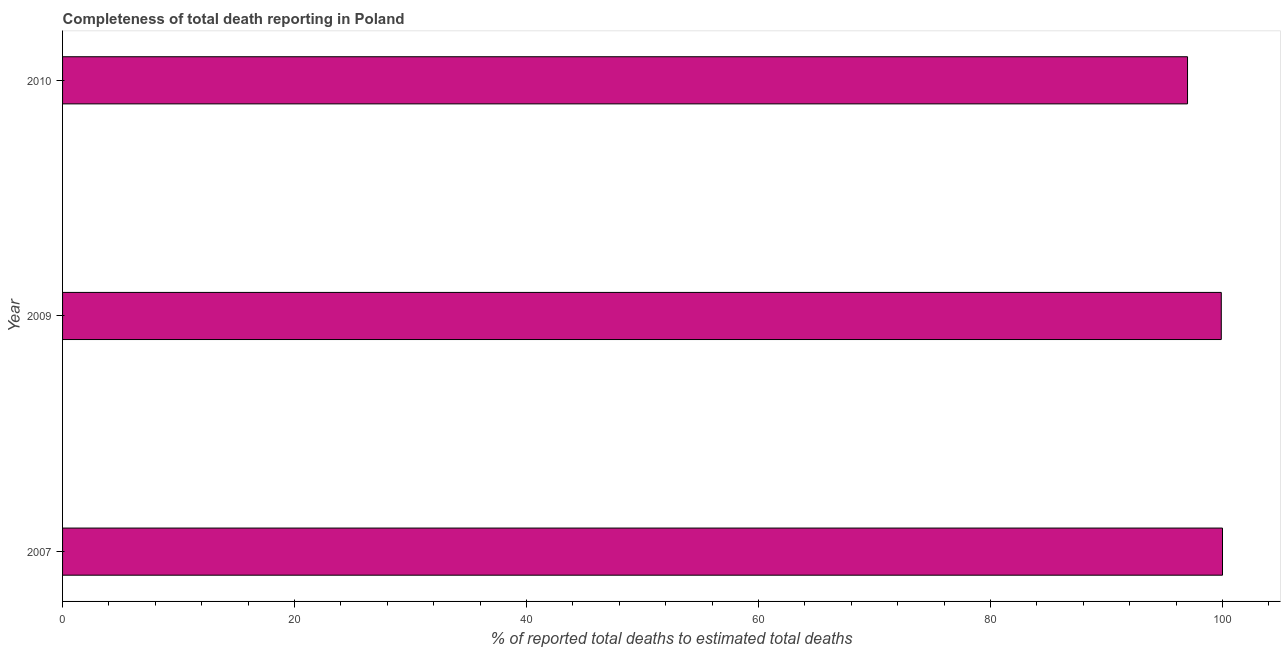Does the graph contain grids?
Give a very brief answer. No. What is the title of the graph?
Offer a terse response. Completeness of total death reporting in Poland. What is the label or title of the X-axis?
Make the answer very short. % of reported total deaths to estimated total deaths. Across all years, what is the maximum completeness of total death reports?
Offer a very short reply. 100. Across all years, what is the minimum completeness of total death reports?
Your response must be concise. 96.99. In which year was the completeness of total death reports maximum?
Keep it short and to the point. 2007. What is the sum of the completeness of total death reports?
Offer a terse response. 296.88. What is the difference between the completeness of total death reports in 2007 and 2010?
Offer a terse response. 3.01. What is the average completeness of total death reports per year?
Provide a short and direct response. 98.96. What is the median completeness of total death reports?
Keep it short and to the point. 99.89. Do a majority of the years between 2007 and 2010 (inclusive) have completeness of total death reports greater than 36 %?
Provide a succinct answer. Yes. What is the ratio of the completeness of total death reports in 2009 to that in 2010?
Offer a very short reply. 1.03. Is the difference between the completeness of total death reports in 2007 and 2009 greater than the difference between any two years?
Offer a very short reply. No. What is the difference between the highest and the second highest completeness of total death reports?
Keep it short and to the point. 0.1. Is the sum of the completeness of total death reports in 2007 and 2009 greater than the maximum completeness of total death reports across all years?
Make the answer very short. Yes. What is the difference between the highest and the lowest completeness of total death reports?
Make the answer very short. 3.01. How many bars are there?
Provide a succinct answer. 3. How many years are there in the graph?
Make the answer very short. 3. What is the difference between two consecutive major ticks on the X-axis?
Offer a very short reply. 20. Are the values on the major ticks of X-axis written in scientific E-notation?
Ensure brevity in your answer.  No. What is the % of reported total deaths to estimated total deaths in 2007?
Ensure brevity in your answer.  100. What is the % of reported total deaths to estimated total deaths of 2009?
Provide a succinct answer. 99.89. What is the % of reported total deaths to estimated total deaths of 2010?
Your answer should be compact. 96.99. What is the difference between the % of reported total deaths to estimated total deaths in 2007 and 2009?
Keep it short and to the point. 0.11. What is the difference between the % of reported total deaths to estimated total deaths in 2007 and 2010?
Your answer should be compact. 3.01. What is the difference between the % of reported total deaths to estimated total deaths in 2009 and 2010?
Give a very brief answer. 2.91. What is the ratio of the % of reported total deaths to estimated total deaths in 2007 to that in 2009?
Offer a terse response. 1. What is the ratio of the % of reported total deaths to estimated total deaths in 2007 to that in 2010?
Ensure brevity in your answer.  1.03. What is the ratio of the % of reported total deaths to estimated total deaths in 2009 to that in 2010?
Your answer should be compact. 1.03. 